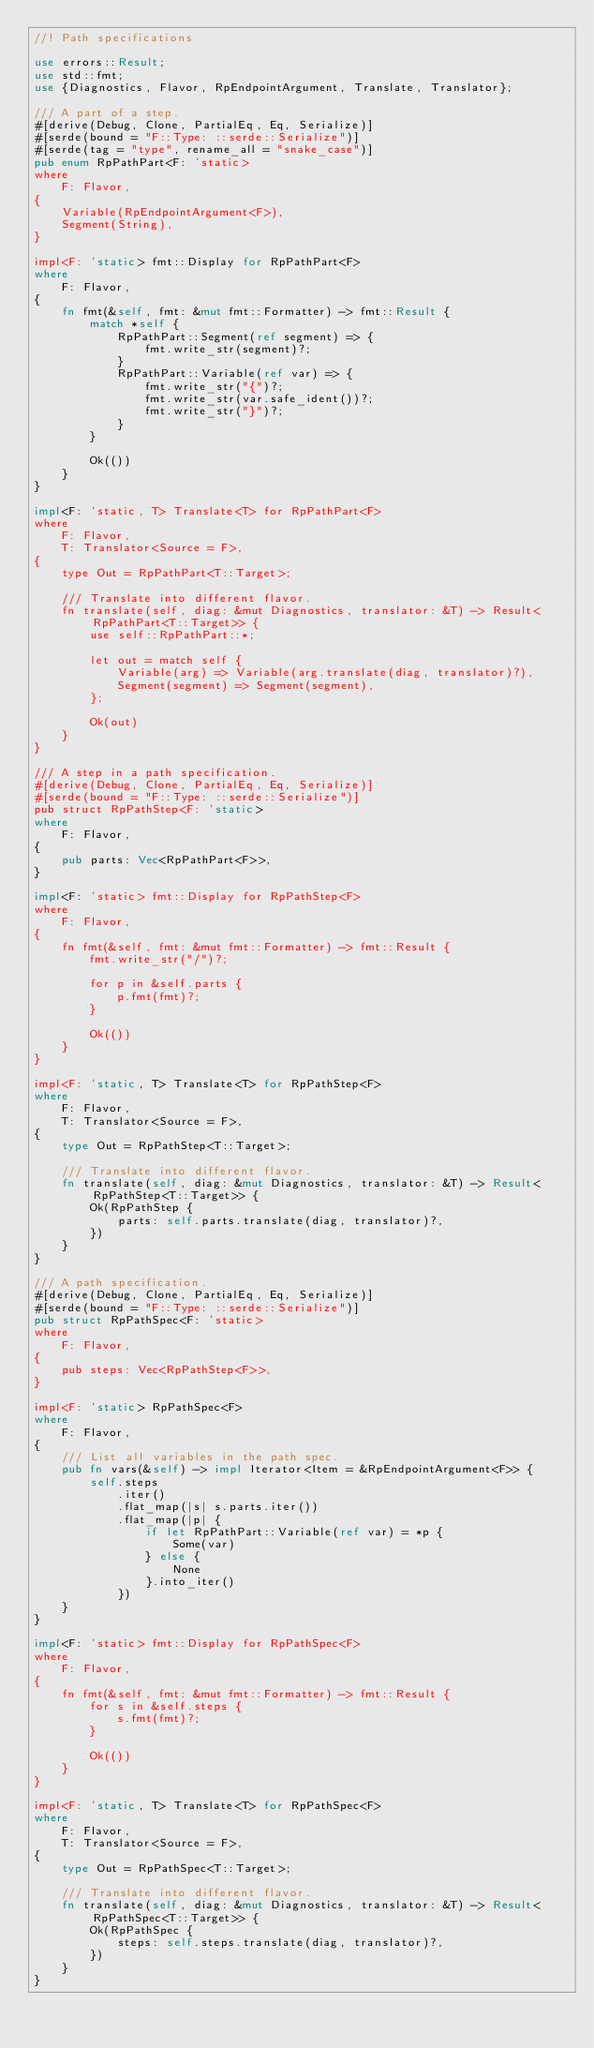Convert code to text. <code><loc_0><loc_0><loc_500><loc_500><_Rust_>//! Path specifications

use errors::Result;
use std::fmt;
use {Diagnostics, Flavor, RpEndpointArgument, Translate, Translator};

/// A part of a step.
#[derive(Debug, Clone, PartialEq, Eq, Serialize)]
#[serde(bound = "F::Type: ::serde::Serialize")]
#[serde(tag = "type", rename_all = "snake_case")]
pub enum RpPathPart<F: 'static>
where
    F: Flavor,
{
    Variable(RpEndpointArgument<F>),
    Segment(String),
}

impl<F: 'static> fmt::Display for RpPathPart<F>
where
    F: Flavor,
{
    fn fmt(&self, fmt: &mut fmt::Formatter) -> fmt::Result {
        match *self {
            RpPathPart::Segment(ref segment) => {
                fmt.write_str(segment)?;
            }
            RpPathPart::Variable(ref var) => {
                fmt.write_str("{")?;
                fmt.write_str(var.safe_ident())?;
                fmt.write_str("}")?;
            }
        }

        Ok(())
    }
}

impl<F: 'static, T> Translate<T> for RpPathPart<F>
where
    F: Flavor,
    T: Translator<Source = F>,
{
    type Out = RpPathPart<T::Target>;

    /// Translate into different flavor.
    fn translate(self, diag: &mut Diagnostics, translator: &T) -> Result<RpPathPart<T::Target>> {
        use self::RpPathPart::*;

        let out = match self {
            Variable(arg) => Variable(arg.translate(diag, translator)?),
            Segment(segment) => Segment(segment),
        };

        Ok(out)
    }
}

/// A step in a path specification.
#[derive(Debug, Clone, PartialEq, Eq, Serialize)]
#[serde(bound = "F::Type: ::serde::Serialize")]
pub struct RpPathStep<F: 'static>
where
    F: Flavor,
{
    pub parts: Vec<RpPathPart<F>>,
}

impl<F: 'static> fmt::Display for RpPathStep<F>
where
    F: Flavor,
{
    fn fmt(&self, fmt: &mut fmt::Formatter) -> fmt::Result {
        fmt.write_str("/")?;

        for p in &self.parts {
            p.fmt(fmt)?;
        }

        Ok(())
    }
}

impl<F: 'static, T> Translate<T> for RpPathStep<F>
where
    F: Flavor,
    T: Translator<Source = F>,
{
    type Out = RpPathStep<T::Target>;

    /// Translate into different flavor.
    fn translate(self, diag: &mut Diagnostics, translator: &T) -> Result<RpPathStep<T::Target>> {
        Ok(RpPathStep {
            parts: self.parts.translate(diag, translator)?,
        })
    }
}

/// A path specification.
#[derive(Debug, Clone, PartialEq, Eq, Serialize)]
#[serde(bound = "F::Type: ::serde::Serialize")]
pub struct RpPathSpec<F: 'static>
where
    F: Flavor,
{
    pub steps: Vec<RpPathStep<F>>,
}

impl<F: 'static> RpPathSpec<F>
where
    F: Flavor,
{
    /// List all variables in the path spec.
    pub fn vars(&self) -> impl Iterator<Item = &RpEndpointArgument<F>> {
        self.steps
            .iter()
            .flat_map(|s| s.parts.iter())
            .flat_map(|p| {
                if let RpPathPart::Variable(ref var) = *p {
                    Some(var)
                } else {
                    None
                }.into_iter()
            })
    }
}

impl<F: 'static> fmt::Display for RpPathSpec<F>
where
    F: Flavor,
{
    fn fmt(&self, fmt: &mut fmt::Formatter) -> fmt::Result {
        for s in &self.steps {
            s.fmt(fmt)?;
        }

        Ok(())
    }
}

impl<F: 'static, T> Translate<T> for RpPathSpec<F>
where
    F: Flavor,
    T: Translator<Source = F>,
{
    type Out = RpPathSpec<T::Target>;

    /// Translate into different flavor.
    fn translate(self, diag: &mut Diagnostics, translator: &T) -> Result<RpPathSpec<T::Target>> {
        Ok(RpPathSpec {
            steps: self.steps.translate(diag, translator)?,
        })
    }
}
</code> 